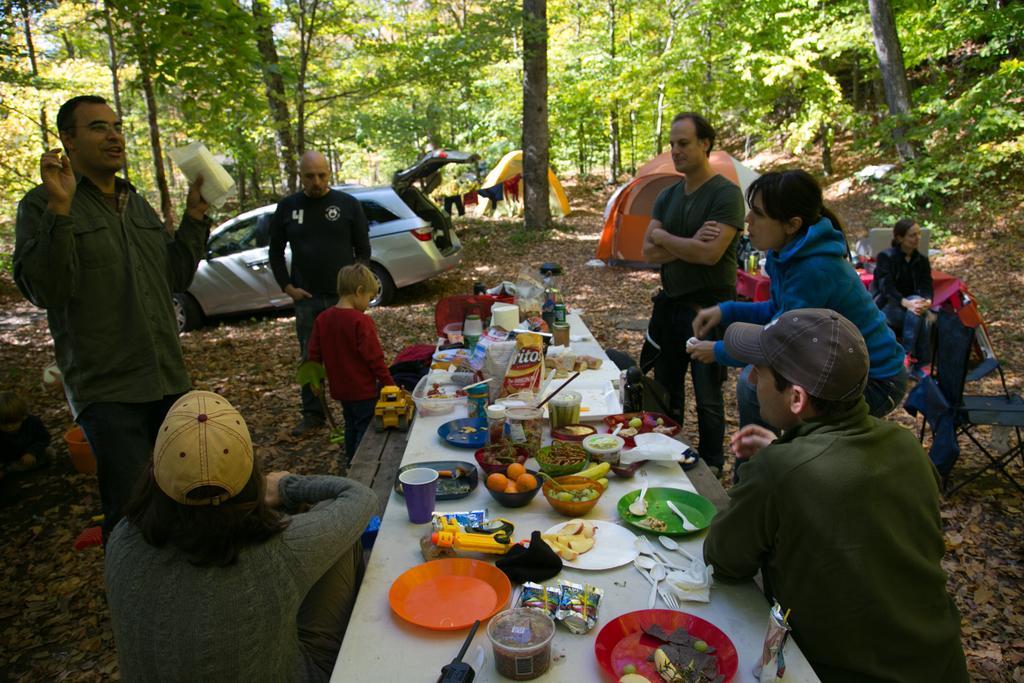In one or two sentences, can you explain what this image depicts? This picture is clicked in a forest. In front of the picture, we see a table on which plate, box, glass, plastic covers, bowl, spoon, fruits and some eatables are placed on it. We see many people in this picture. The man in green t-shirt wearing brown cap is sitting on a chair and on background, we see a car and orange and white tent. Behind that, we see many trees and also yellow tent. 